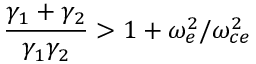<formula> <loc_0><loc_0><loc_500><loc_500>\frac { \gamma _ { 1 } + \gamma _ { 2 } } { \gamma _ { 1 } \gamma _ { 2 } } > 1 + \omega _ { e } ^ { 2 } / \omega _ { c e } ^ { 2 }</formula> 